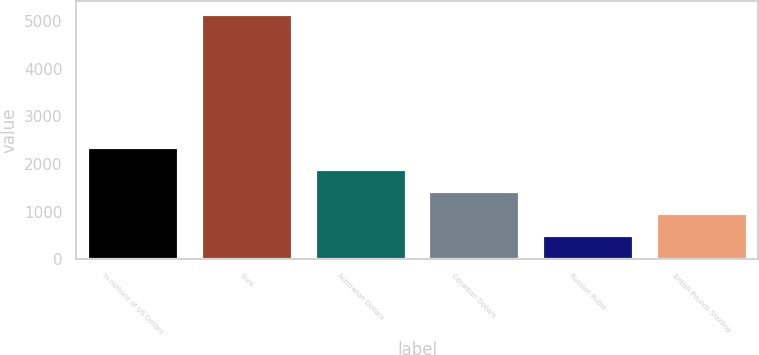Convert chart. <chart><loc_0><loc_0><loc_500><loc_500><bar_chart><fcel>In millions of US Dollars<fcel>Euro<fcel>Australian Dollars<fcel>Canadian Dollars<fcel>Russian Ruble<fcel>British Pounds Sterling<nl><fcel>2361<fcel>5151<fcel>1896<fcel>1431<fcel>501<fcel>966<nl></chart> 